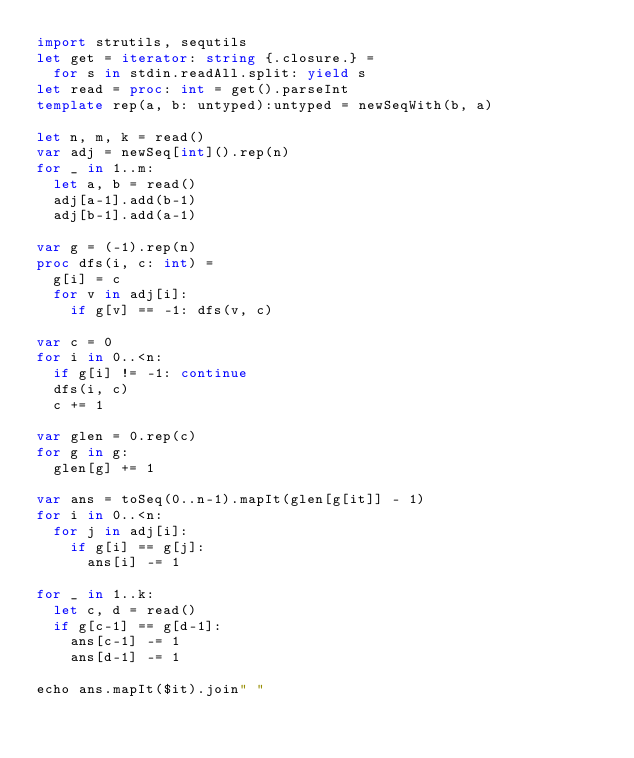<code> <loc_0><loc_0><loc_500><loc_500><_Nim_>import strutils, sequtils
let get = iterator: string {.closure.} =
  for s in stdin.readAll.split: yield s
let read = proc: int = get().parseInt
template rep(a, b: untyped):untyped = newSeqWith(b, a)

let n, m, k = read()
var adj = newSeq[int]().rep(n)
for _ in 1..m:
  let a, b = read()
  adj[a-1].add(b-1)
  adj[b-1].add(a-1)

var g = (-1).rep(n)
proc dfs(i, c: int) =
  g[i] = c
  for v in adj[i]:
    if g[v] == -1: dfs(v, c)

var c = 0
for i in 0..<n:
  if g[i] != -1: continue
  dfs(i, c)
  c += 1

var glen = 0.rep(c)
for g in g:
  glen[g] += 1

var ans = toSeq(0..n-1).mapIt(glen[g[it]] - 1)
for i in 0..<n:
  for j in adj[i]:
    if g[i] == g[j]:
      ans[i] -= 1

for _ in 1..k:
  let c, d = read()
  if g[c-1] == g[d-1]:
    ans[c-1] -= 1
    ans[d-1] -= 1

echo ans.mapIt($it).join" "</code> 